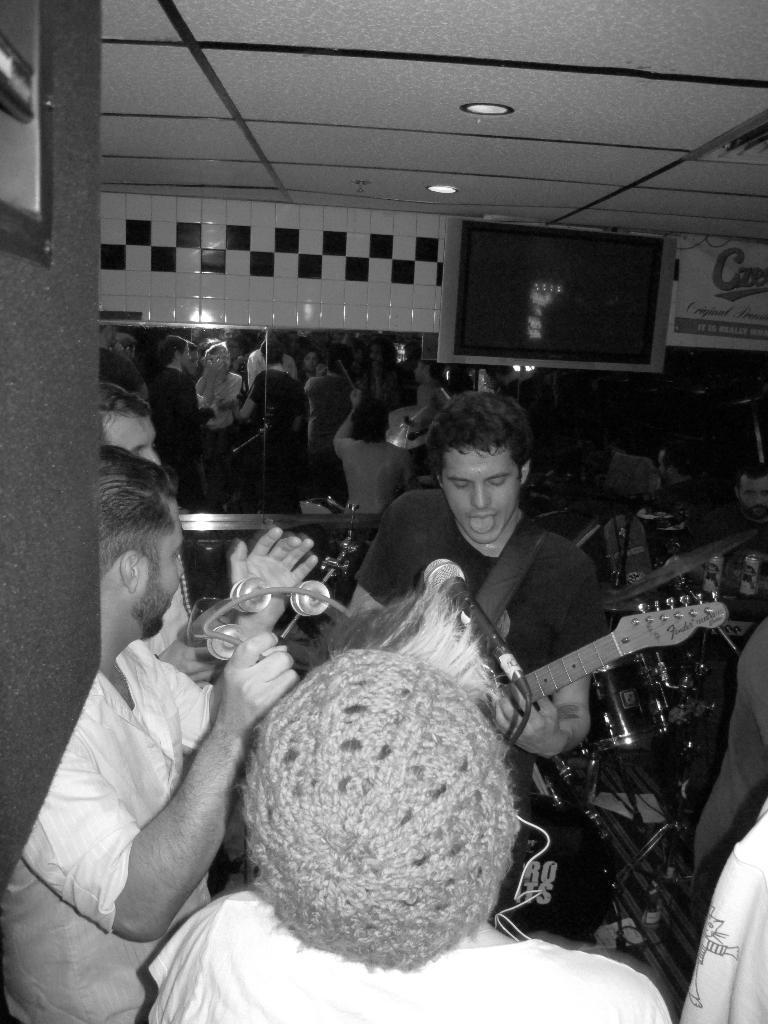Describe this image in one or two sentences. This is a picture of a group band. In the center of the image there is a person playing guitar. On the left there is a person playing a musical instrument. In the background there is a mirror. On the top right there is television. On the right there are drums. On the top there is ceiling with lights. 